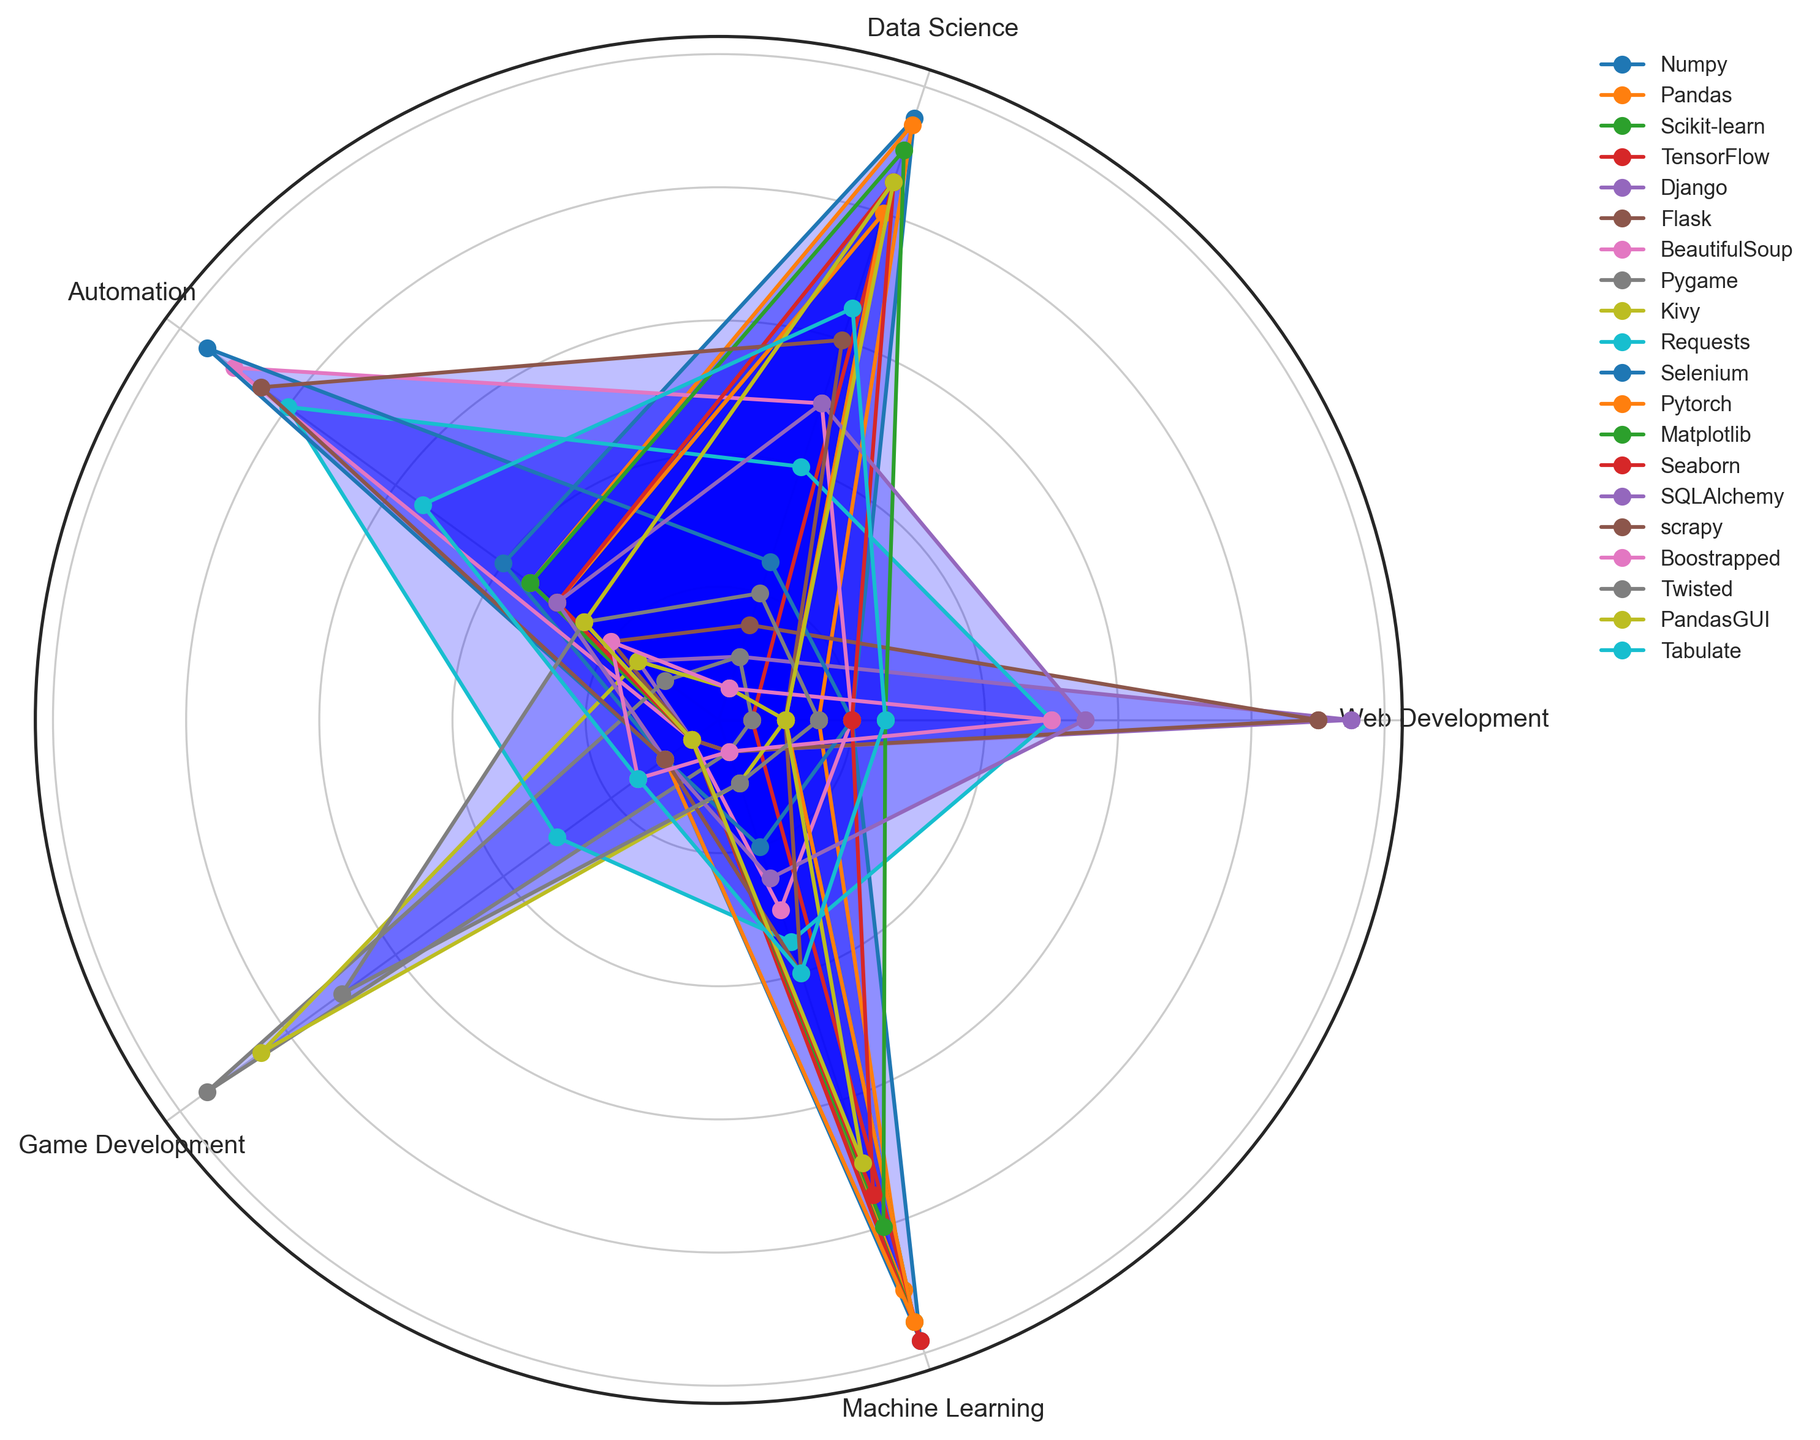What is the most frequently used library for Web Development? Based on the radar chart, the library that has the highest value under Web Development is Django with a value of 95.
Answer: Django Which library is equally used in Web Development and Game Development? The radar chart shows the values for all libraries in two different categories, Web Development and Game Development. Requests have equal values of 30 in both categories.
Answer: Requests How does Pandas usage in Data Science compare to TensorFlow and Numpy? For Data Science, Pandas has a value of 94, TensorFlow has 85, and Numpy has 95. Clearly, Pandas (94) is slightly lower than Numpy (95) but higher than TensorFlow (85).
Answer: Pandas is higher than TensorFlow but lower than Numpy Which industry sector shows the highest usage of Matplotlib? Refer to the radar chart segment for each sector under Matplotlib, and the highest value is for Data Science, which is 90.
Answer: Data Science In which industry sector is BeautifulSoup least utilized? Evaluate the values of BeautifulSoup across all sectors, the smallest value shown is for Game Development, which is 5.
Answer: Game Development What is the average usage of Requests across all industry sectors? Requests have values of 50 (Web Development), 40 (Data Science), 80 (Automation), 30 (Game Development), and 35 (Machine Learning). Calculate the average: (50+40+80+30+35) / 5 = 47.
Answer: 47 Which libraries have the highest value for Game Development? For the Game Development sector, the highest value displayed on the radar chart is 95 for Pygame.
Answer: Pygame How does the usage of Seaborn in Machine Learning compare to its usage in Data Science? Seaborn has a value of 75 in Machine Learning and 85 in Data Science. First, identify the values from the chart and then compare them.
Answer: Seaborn is less used in Machine Learning Compare the average usage percentage of PandasGUI in Automation and Game Development. PandasGUI has a usage of 25 in Automation and 5 in Game Development. Calculate the average for both: (25 + 5) / 2 = 15.
Answer: 15 Which library is used more frequently in Web Development, Flask or Django? Compare the Web Development values for Flask (90) and Django (95) from the radar chart; Django has a higher value.
Answer: Django 